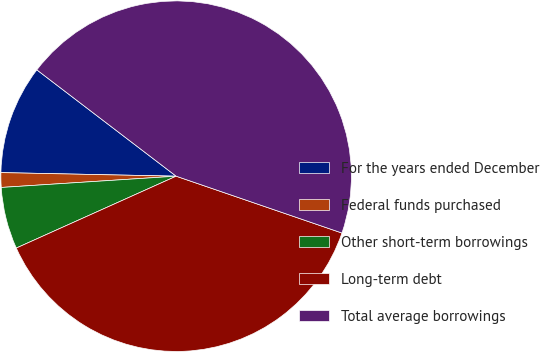Convert chart to OTSL. <chart><loc_0><loc_0><loc_500><loc_500><pie_chart><fcel>For the years ended December<fcel>Federal funds purchased<fcel>Other short-term borrowings<fcel>Long-term debt<fcel>Total average borrowings<nl><fcel>10.05%<fcel>1.35%<fcel>5.7%<fcel>38.02%<fcel>44.88%<nl></chart> 